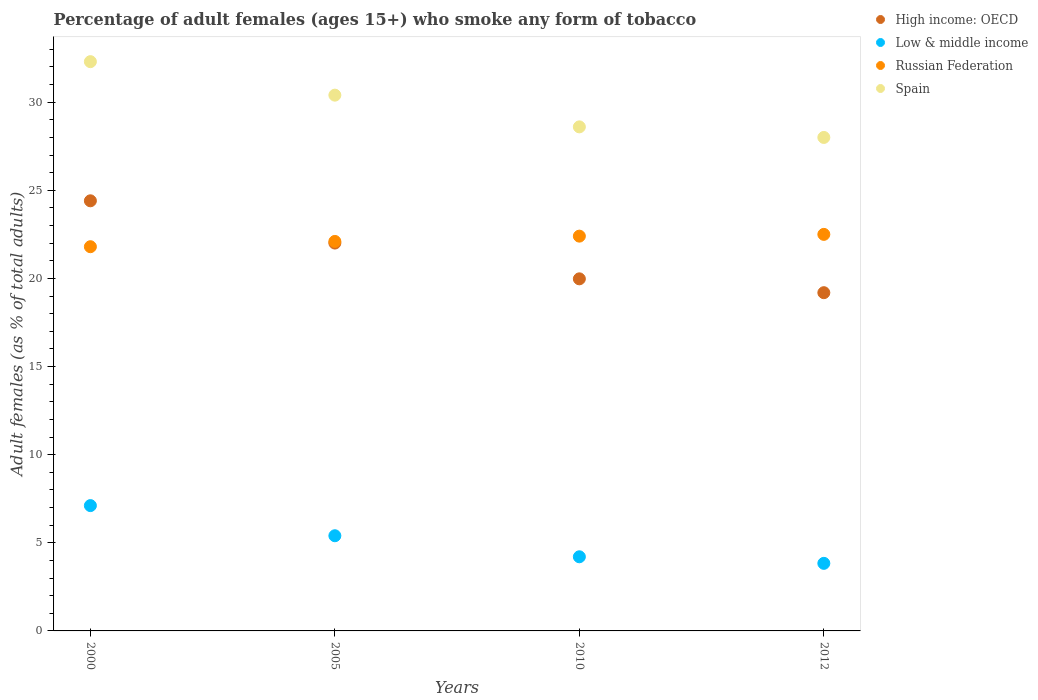How many different coloured dotlines are there?
Make the answer very short. 4. What is the percentage of adult females who smoke in High income: OECD in 2012?
Offer a very short reply. 19.19. What is the total percentage of adult females who smoke in Russian Federation in the graph?
Make the answer very short. 88.8. What is the difference between the percentage of adult females who smoke in Low & middle income in 2010 and that in 2012?
Give a very brief answer. 0.37. What is the difference between the percentage of adult females who smoke in Russian Federation in 2005 and the percentage of adult females who smoke in Spain in 2010?
Provide a short and direct response. -6.5. What is the average percentage of adult females who smoke in Low & middle income per year?
Provide a short and direct response. 5.14. In the year 2005, what is the difference between the percentage of adult females who smoke in Spain and percentage of adult females who smoke in Russian Federation?
Keep it short and to the point. 8.3. What is the ratio of the percentage of adult females who smoke in High income: OECD in 2000 to that in 2005?
Your response must be concise. 1.11. Is the difference between the percentage of adult females who smoke in Spain in 2000 and 2005 greater than the difference between the percentage of adult females who smoke in Russian Federation in 2000 and 2005?
Ensure brevity in your answer.  Yes. What is the difference between the highest and the second highest percentage of adult females who smoke in Spain?
Your answer should be very brief. 1.9. What is the difference between the highest and the lowest percentage of adult females who smoke in High income: OECD?
Ensure brevity in your answer.  5.21. Is the sum of the percentage of adult females who smoke in Low & middle income in 2000 and 2005 greater than the maximum percentage of adult females who smoke in High income: OECD across all years?
Give a very brief answer. No. Is it the case that in every year, the sum of the percentage of adult females who smoke in Low & middle income and percentage of adult females who smoke in Spain  is greater than the sum of percentage of adult females who smoke in High income: OECD and percentage of adult females who smoke in Russian Federation?
Make the answer very short. No. Is the percentage of adult females who smoke in Spain strictly greater than the percentage of adult females who smoke in Low & middle income over the years?
Offer a terse response. Yes. Is the percentage of adult females who smoke in Russian Federation strictly less than the percentage of adult females who smoke in Spain over the years?
Provide a succinct answer. Yes. What is the difference between two consecutive major ticks on the Y-axis?
Your response must be concise. 5. Are the values on the major ticks of Y-axis written in scientific E-notation?
Ensure brevity in your answer.  No. Does the graph contain any zero values?
Keep it short and to the point. No. Where does the legend appear in the graph?
Offer a terse response. Top right. How many legend labels are there?
Give a very brief answer. 4. What is the title of the graph?
Keep it short and to the point. Percentage of adult females (ages 15+) who smoke any form of tobacco. What is the label or title of the Y-axis?
Ensure brevity in your answer.  Adult females (as % of total adults). What is the Adult females (as % of total adults) of High income: OECD in 2000?
Give a very brief answer. 24.4. What is the Adult females (as % of total adults) of Low & middle income in 2000?
Ensure brevity in your answer.  7.11. What is the Adult females (as % of total adults) in Russian Federation in 2000?
Make the answer very short. 21.8. What is the Adult females (as % of total adults) in Spain in 2000?
Provide a succinct answer. 32.3. What is the Adult females (as % of total adults) of High income: OECD in 2005?
Ensure brevity in your answer.  22.01. What is the Adult females (as % of total adults) in Low & middle income in 2005?
Your response must be concise. 5.4. What is the Adult females (as % of total adults) of Russian Federation in 2005?
Your response must be concise. 22.1. What is the Adult females (as % of total adults) of Spain in 2005?
Your answer should be very brief. 30.4. What is the Adult females (as % of total adults) in High income: OECD in 2010?
Offer a terse response. 19.98. What is the Adult females (as % of total adults) in Low & middle income in 2010?
Make the answer very short. 4.21. What is the Adult females (as % of total adults) in Russian Federation in 2010?
Keep it short and to the point. 22.4. What is the Adult females (as % of total adults) in Spain in 2010?
Provide a short and direct response. 28.6. What is the Adult females (as % of total adults) of High income: OECD in 2012?
Your answer should be very brief. 19.19. What is the Adult females (as % of total adults) of Low & middle income in 2012?
Provide a succinct answer. 3.83. What is the Adult females (as % of total adults) of Russian Federation in 2012?
Your response must be concise. 22.5. What is the Adult females (as % of total adults) of Spain in 2012?
Ensure brevity in your answer.  28. Across all years, what is the maximum Adult females (as % of total adults) of High income: OECD?
Provide a succinct answer. 24.4. Across all years, what is the maximum Adult females (as % of total adults) in Low & middle income?
Offer a terse response. 7.11. Across all years, what is the maximum Adult females (as % of total adults) in Russian Federation?
Your answer should be very brief. 22.5. Across all years, what is the maximum Adult females (as % of total adults) of Spain?
Your answer should be very brief. 32.3. Across all years, what is the minimum Adult females (as % of total adults) in High income: OECD?
Your response must be concise. 19.19. Across all years, what is the minimum Adult females (as % of total adults) of Low & middle income?
Give a very brief answer. 3.83. Across all years, what is the minimum Adult females (as % of total adults) in Russian Federation?
Your answer should be compact. 21.8. Across all years, what is the minimum Adult females (as % of total adults) in Spain?
Your answer should be very brief. 28. What is the total Adult females (as % of total adults) in High income: OECD in the graph?
Keep it short and to the point. 85.58. What is the total Adult females (as % of total adults) of Low & middle income in the graph?
Offer a very short reply. 20.55. What is the total Adult females (as % of total adults) in Russian Federation in the graph?
Give a very brief answer. 88.8. What is the total Adult females (as % of total adults) of Spain in the graph?
Make the answer very short. 119.3. What is the difference between the Adult females (as % of total adults) of High income: OECD in 2000 and that in 2005?
Offer a terse response. 2.4. What is the difference between the Adult females (as % of total adults) of Low & middle income in 2000 and that in 2005?
Your response must be concise. 1.71. What is the difference between the Adult females (as % of total adults) in High income: OECD in 2000 and that in 2010?
Your answer should be very brief. 4.43. What is the difference between the Adult females (as % of total adults) of Low & middle income in 2000 and that in 2010?
Keep it short and to the point. 2.9. What is the difference between the Adult females (as % of total adults) in Russian Federation in 2000 and that in 2010?
Provide a succinct answer. -0.6. What is the difference between the Adult females (as % of total adults) of High income: OECD in 2000 and that in 2012?
Offer a very short reply. 5.21. What is the difference between the Adult females (as % of total adults) of Low & middle income in 2000 and that in 2012?
Provide a short and direct response. 3.28. What is the difference between the Adult females (as % of total adults) in Russian Federation in 2000 and that in 2012?
Your response must be concise. -0.7. What is the difference between the Adult females (as % of total adults) of High income: OECD in 2005 and that in 2010?
Make the answer very short. 2.03. What is the difference between the Adult females (as % of total adults) of Low & middle income in 2005 and that in 2010?
Your answer should be compact. 1.19. What is the difference between the Adult females (as % of total adults) in Russian Federation in 2005 and that in 2010?
Offer a very short reply. -0.3. What is the difference between the Adult females (as % of total adults) in Spain in 2005 and that in 2010?
Keep it short and to the point. 1.8. What is the difference between the Adult females (as % of total adults) in High income: OECD in 2005 and that in 2012?
Give a very brief answer. 2.82. What is the difference between the Adult females (as % of total adults) of Low & middle income in 2005 and that in 2012?
Offer a terse response. 1.57. What is the difference between the Adult females (as % of total adults) in Russian Federation in 2005 and that in 2012?
Keep it short and to the point. -0.4. What is the difference between the Adult females (as % of total adults) in High income: OECD in 2010 and that in 2012?
Provide a short and direct response. 0.79. What is the difference between the Adult females (as % of total adults) in Low & middle income in 2010 and that in 2012?
Make the answer very short. 0.37. What is the difference between the Adult females (as % of total adults) of Russian Federation in 2010 and that in 2012?
Provide a short and direct response. -0.1. What is the difference between the Adult females (as % of total adults) of High income: OECD in 2000 and the Adult females (as % of total adults) of Low & middle income in 2005?
Give a very brief answer. 19. What is the difference between the Adult females (as % of total adults) of High income: OECD in 2000 and the Adult females (as % of total adults) of Russian Federation in 2005?
Ensure brevity in your answer.  2.3. What is the difference between the Adult females (as % of total adults) of High income: OECD in 2000 and the Adult females (as % of total adults) of Spain in 2005?
Offer a terse response. -6. What is the difference between the Adult females (as % of total adults) in Low & middle income in 2000 and the Adult females (as % of total adults) in Russian Federation in 2005?
Offer a very short reply. -14.99. What is the difference between the Adult females (as % of total adults) of Low & middle income in 2000 and the Adult females (as % of total adults) of Spain in 2005?
Provide a short and direct response. -23.29. What is the difference between the Adult females (as % of total adults) in Russian Federation in 2000 and the Adult females (as % of total adults) in Spain in 2005?
Ensure brevity in your answer.  -8.6. What is the difference between the Adult females (as % of total adults) in High income: OECD in 2000 and the Adult females (as % of total adults) in Low & middle income in 2010?
Offer a very short reply. 20.2. What is the difference between the Adult females (as % of total adults) in High income: OECD in 2000 and the Adult females (as % of total adults) in Russian Federation in 2010?
Your answer should be compact. 2. What is the difference between the Adult females (as % of total adults) of High income: OECD in 2000 and the Adult females (as % of total adults) of Spain in 2010?
Provide a short and direct response. -4.2. What is the difference between the Adult females (as % of total adults) in Low & middle income in 2000 and the Adult females (as % of total adults) in Russian Federation in 2010?
Make the answer very short. -15.29. What is the difference between the Adult females (as % of total adults) in Low & middle income in 2000 and the Adult females (as % of total adults) in Spain in 2010?
Offer a terse response. -21.49. What is the difference between the Adult females (as % of total adults) of High income: OECD in 2000 and the Adult females (as % of total adults) of Low & middle income in 2012?
Your response must be concise. 20.57. What is the difference between the Adult females (as % of total adults) in High income: OECD in 2000 and the Adult females (as % of total adults) in Russian Federation in 2012?
Your response must be concise. 1.9. What is the difference between the Adult females (as % of total adults) in High income: OECD in 2000 and the Adult females (as % of total adults) in Spain in 2012?
Your response must be concise. -3.6. What is the difference between the Adult females (as % of total adults) of Low & middle income in 2000 and the Adult females (as % of total adults) of Russian Federation in 2012?
Give a very brief answer. -15.39. What is the difference between the Adult females (as % of total adults) of Low & middle income in 2000 and the Adult females (as % of total adults) of Spain in 2012?
Offer a terse response. -20.89. What is the difference between the Adult females (as % of total adults) in High income: OECD in 2005 and the Adult females (as % of total adults) in Low & middle income in 2010?
Provide a short and direct response. 17.8. What is the difference between the Adult females (as % of total adults) of High income: OECD in 2005 and the Adult females (as % of total adults) of Russian Federation in 2010?
Your answer should be compact. -0.39. What is the difference between the Adult females (as % of total adults) of High income: OECD in 2005 and the Adult females (as % of total adults) of Spain in 2010?
Keep it short and to the point. -6.59. What is the difference between the Adult females (as % of total adults) of Low & middle income in 2005 and the Adult females (as % of total adults) of Russian Federation in 2010?
Offer a terse response. -17. What is the difference between the Adult females (as % of total adults) of Low & middle income in 2005 and the Adult females (as % of total adults) of Spain in 2010?
Your answer should be compact. -23.2. What is the difference between the Adult females (as % of total adults) in Russian Federation in 2005 and the Adult females (as % of total adults) in Spain in 2010?
Offer a terse response. -6.5. What is the difference between the Adult females (as % of total adults) of High income: OECD in 2005 and the Adult females (as % of total adults) of Low & middle income in 2012?
Your response must be concise. 18.17. What is the difference between the Adult females (as % of total adults) of High income: OECD in 2005 and the Adult females (as % of total adults) of Russian Federation in 2012?
Keep it short and to the point. -0.49. What is the difference between the Adult females (as % of total adults) of High income: OECD in 2005 and the Adult females (as % of total adults) of Spain in 2012?
Offer a very short reply. -5.99. What is the difference between the Adult females (as % of total adults) of Low & middle income in 2005 and the Adult females (as % of total adults) of Russian Federation in 2012?
Offer a terse response. -17.1. What is the difference between the Adult females (as % of total adults) of Low & middle income in 2005 and the Adult females (as % of total adults) of Spain in 2012?
Make the answer very short. -22.6. What is the difference between the Adult females (as % of total adults) of Russian Federation in 2005 and the Adult females (as % of total adults) of Spain in 2012?
Give a very brief answer. -5.9. What is the difference between the Adult females (as % of total adults) in High income: OECD in 2010 and the Adult females (as % of total adults) in Low & middle income in 2012?
Offer a terse response. 16.14. What is the difference between the Adult females (as % of total adults) of High income: OECD in 2010 and the Adult females (as % of total adults) of Russian Federation in 2012?
Your response must be concise. -2.52. What is the difference between the Adult females (as % of total adults) in High income: OECD in 2010 and the Adult females (as % of total adults) in Spain in 2012?
Offer a very short reply. -8.02. What is the difference between the Adult females (as % of total adults) of Low & middle income in 2010 and the Adult females (as % of total adults) of Russian Federation in 2012?
Offer a terse response. -18.29. What is the difference between the Adult females (as % of total adults) of Low & middle income in 2010 and the Adult females (as % of total adults) of Spain in 2012?
Your answer should be compact. -23.79. What is the difference between the Adult females (as % of total adults) of Russian Federation in 2010 and the Adult females (as % of total adults) of Spain in 2012?
Give a very brief answer. -5.6. What is the average Adult females (as % of total adults) of High income: OECD per year?
Keep it short and to the point. 21.4. What is the average Adult females (as % of total adults) in Low & middle income per year?
Ensure brevity in your answer.  5.14. What is the average Adult females (as % of total adults) in Spain per year?
Offer a terse response. 29.82. In the year 2000, what is the difference between the Adult females (as % of total adults) in High income: OECD and Adult females (as % of total adults) in Low & middle income?
Offer a very short reply. 17.29. In the year 2000, what is the difference between the Adult females (as % of total adults) of High income: OECD and Adult females (as % of total adults) of Russian Federation?
Ensure brevity in your answer.  2.6. In the year 2000, what is the difference between the Adult females (as % of total adults) in High income: OECD and Adult females (as % of total adults) in Spain?
Make the answer very short. -7.9. In the year 2000, what is the difference between the Adult females (as % of total adults) of Low & middle income and Adult females (as % of total adults) of Russian Federation?
Your answer should be compact. -14.69. In the year 2000, what is the difference between the Adult females (as % of total adults) of Low & middle income and Adult females (as % of total adults) of Spain?
Ensure brevity in your answer.  -25.19. In the year 2000, what is the difference between the Adult females (as % of total adults) in Russian Federation and Adult females (as % of total adults) in Spain?
Your response must be concise. -10.5. In the year 2005, what is the difference between the Adult females (as % of total adults) of High income: OECD and Adult females (as % of total adults) of Low & middle income?
Keep it short and to the point. 16.61. In the year 2005, what is the difference between the Adult females (as % of total adults) in High income: OECD and Adult females (as % of total adults) in Russian Federation?
Offer a terse response. -0.09. In the year 2005, what is the difference between the Adult females (as % of total adults) in High income: OECD and Adult females (as % of total adults) in Spain?
Provide a succinct answer. -8.39. In the year 2005, what is the difference between the Adult females (as % of total adults) in Low & middle income and Adult females (as % of total adults) in Russian Federation?
Offer a very short reply. -16.7. In the year 2005, what is the difference between the Adult females (as % of total adults) of Low & middle income and Adult females (as % of total adults) of Spain?
Your response must be concise. -25. In the year 2005, what is the difference between the Adult females (as % of total adults) of Russian Federation and Adult females (as % of total adults) of Spain?
Provide a short and direct response. -8.3. In the year 2010, what is the difference between the Adult females (as % of total adults) in High income: OECD and Adult females (as % of total adults) in Low & middle income?
Keep it short and to the point. 15.77. In the year 2010, what is the difference between the Adult females (as % of total adults) of High income: OECD and Adult females (as % of total adults) of Russian Federation?
Offer a very short reply. -2.42. In the year 2010, what is the difference between the Adult females (as % of total adults) of High income: OECD and Adult females (as % of total adults) of Spain?
Provide a succinct answer. -8.62. In the year 2010, what is the difference between the Adult females (as % of total adults) in Low & middle income and Adult females (as % of total adults) in Russian Federation?
Make the answer very short. -18.19. In the year 2010, what is the difference between the Adult females (as % of total adults) of Low & middle income and Adult females (as % of total adults) of Spain?
Your answer should be compact. -24.39. In the year 2012, what is the difference between the Adult females (as % of total adults) of High income: OECD and Adult females (as % of total adults) of Low & middle income?
Your answer should be compact. 15.36. In the year 2012, what is the difference between the Adult females (as % of total adults) in High income: OECD and Adult females (as % of total adults) in Russian Federation?
Provide a short and direct response. -3.31. In the year 2012, what is the difference between the Adult females (as % of total adults) of High income: OECD and Adult females (as % of total adults) of Spain?
Provide a short and direct response. -8.81. In the year 2012, what is the difference between the Adult females (as % of total adults) in Low & middle income and Adult females (as % of total adults) in Russian Federation?
Offer a terse response. -18.67. In the year 2012, what is the difference between the Adult females (as % of total adults) in Low & middle income and Adult females (as % of total adults) in Spain?
Keep it short and to the point. -24.17. What is the ratio of the Adult females (as % of total adults) of High income: OECD in 2000 to that in 2005?
Offer a very short reply. 1.11. What is the ratio of the Adult females (as % of total adults) of Low & middle income in 2000 to that in 2005?
Your response must be concise. 1.32. What is the ratio of the Adult females (as % of total adults) of Russian Federation in 2000 to that in 2005?
Provide a succinct answer. 0.99. What is the ratio of the Adult females (as % of total adults) of High income: OECD in 2000 to that in 2010?
Offer a terse response. 1.22. What is the ratio of the Adult females (as % of total adults) in Low & middle income in 2000 to that in 2010?
Your answer should be compact. 1.69. What is the ratio of the Adult females (as % of total adults) of Russian Federation in 2000 to that in 2010?
Ensure brevity in your answer.  0.97. What is the ratio of the Adult females (as % of total adults) of Spain in 2000 to that in 2010?
Offer a terse response. 1.13. What is the ratio of the Adult females (as % of total adults) in High income: OECD in 2000 to that in 2012?
Your answer should be compact. 1.27. What is the ratio of the Adult females (as % of total adults) of Low & middle income in 2000 to that in 2012?
Offer a very short reply. 1.85. What is the ratio of the Adult females (as % of total adults) of Russian Federation in 2000 to that in 2012?
Offer a very short reply. 0.97. What is the ratio of the Adult females (as % of total adults) in Spain in 2000 to that in 2012?
Keep it short and to the point. 1.15. What is the ratio of the Adult females (as % of total adults) of High income: OECD in 2005 to that in 2010?
Offer a terse response. 1.1. What is the ratio of the Adult females (as % of total adults) in Low & middle income in 2005 to that in 2010?
Provide a succinct answer. 1.28. What is the ratio of the Adult females (as % of total adults) of Russian Federation in 2005 to that in 2010?
Your response must be concise. 0.99. What is the ratio of the Adult females (as % of total adults) of Spain in 2005 to that in 2010?
Make the answer very short. 1.06. What is the ratio of the Adult females (as % of total adults) of High income: OECD in 2005 to that in 2012?
Give a very brief answer. 1.15. What is the ratio of the Adult females (as % of total adults) of Low & middle income in 2005 to that in 2012?
Your response must be concise. 1.41. What is the ratio of the Adult females (as % of total adults) in Russian Federation in 2005 to that in 2012?
Offer a very short reply. 0.98. What is the ratio of the Adult females (as % of total adults) of Spain in 2005 to that in 2012?
Provide a short and direct response. 1.09. What is the ratio of the Adult females (as % of total adults) of High income: OECD in 2010 to that in 2012?
Ensure brevity in your answer.  1.04. What is the ratio of the Adult females (as % of total adults) in Low & middle income in 2010 to that in 2012?
Your response must be concise. 1.1. What is the ratio of the Adult females (as % of total adults) in Russian Federation in 2010 to that in 2012?
Make the answer very short. 1. What is the ratio of the Adult females (as % of total adults) in Spain in 2010 to that in 2012?
Provide a succinct answer. 1.02. What is the difference between the highest and the second highest Adult females (as % of total adults) of High income: OECD?
Your answer should be compact. 2.4. What is the difference between the highest and the second highest Adult females (as % of total adults) in Low & middle income?
Your answer should be very brief. 1.71. What is the difference between the highest and the second highest Adult females (as % of total adults) in Russian Federation?
Give a very brief answer. 0.1. What is the difference between the highest and the lowest Adult females (as % of total adults) in High income: OECD?
Offer a very short reply. 5.21. What is the difference between the highest and the lowest Adult females (as % of total adults) of Low & middle income?
Offer a very short reply. 3.28. 